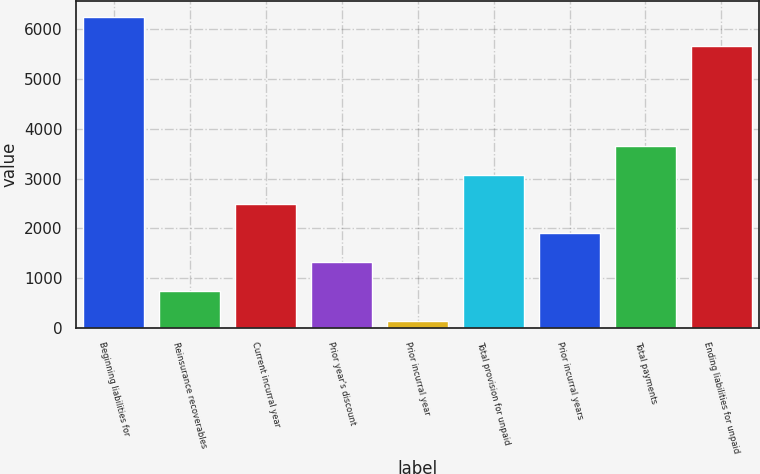<chart> <loc_0><loc_0><loc_500><loc_500><bar_chart><fcel>Beginning liabilities for<fcel>Reinsurance recoverables<fcel>Current incurral year<fcel>Prior year's discount<fcel>Prior incurral year<fcel>Total provision for unpaid<fcel>Prior incurral years<fcel>Total payments<fcel>Ending liabilities for unpaid<nl><fcel>6257.7<fcel>732.7<fcel>2492.8<fcel>1319.4<fcel>146<fcel>3079.5<fcel>1906.1<fcel>3666.2<fcel>5671<nl></chart> 